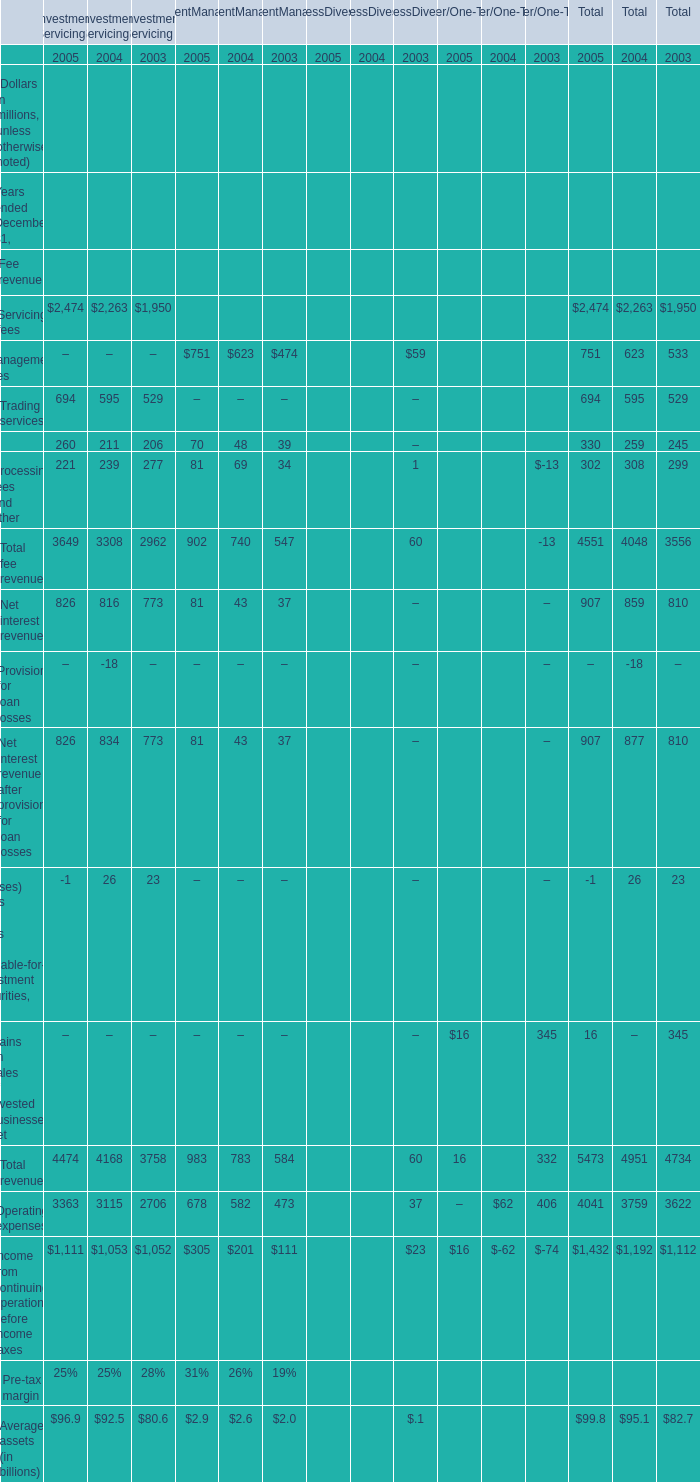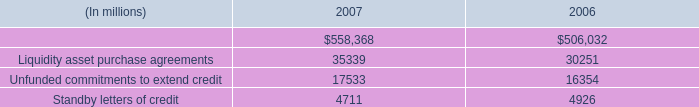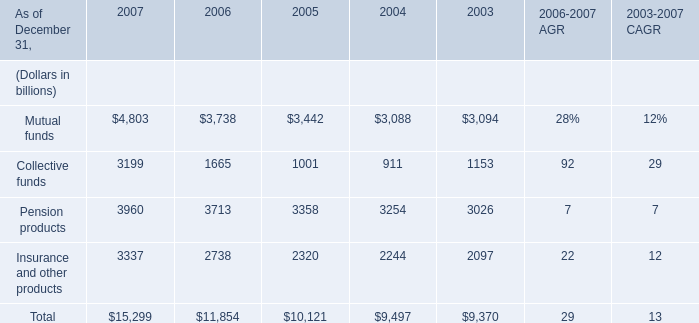What's the average of Indemnified securities financing of 2007, and Insurance and other products of 2004 ? 
Computations: ((558368.0 + 2244.0) / 2)
Answer: 280306.0. 